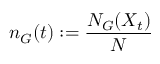<formula> <loc_0><loc_0><loc_500><loc_500>n _ { G } ( t ) \colon = \frac { N _ { G } ( X _ { t } ) } { N }</formula> 